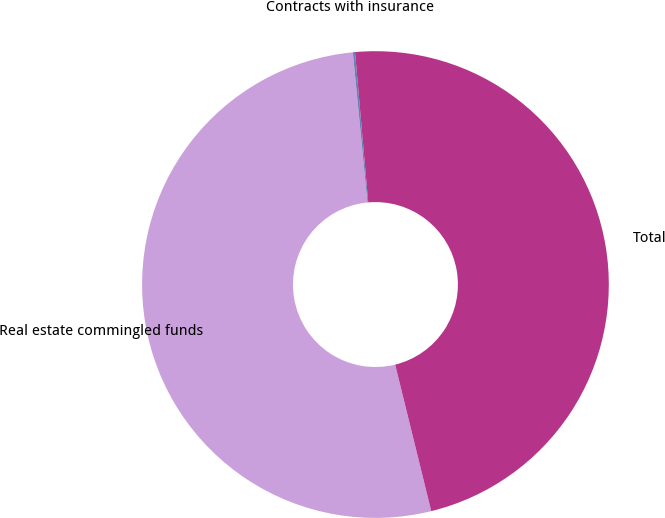Convert chart. <chart><loc_0><loc_0><loc_500><loc_500><pie_chart><fcel>Real estate commingled funds<fcel>Contracts with insurance<fcel>Total<nl><fcel>52.3%<fcel>0.15%<fcel>47.55%<nl></chart> 